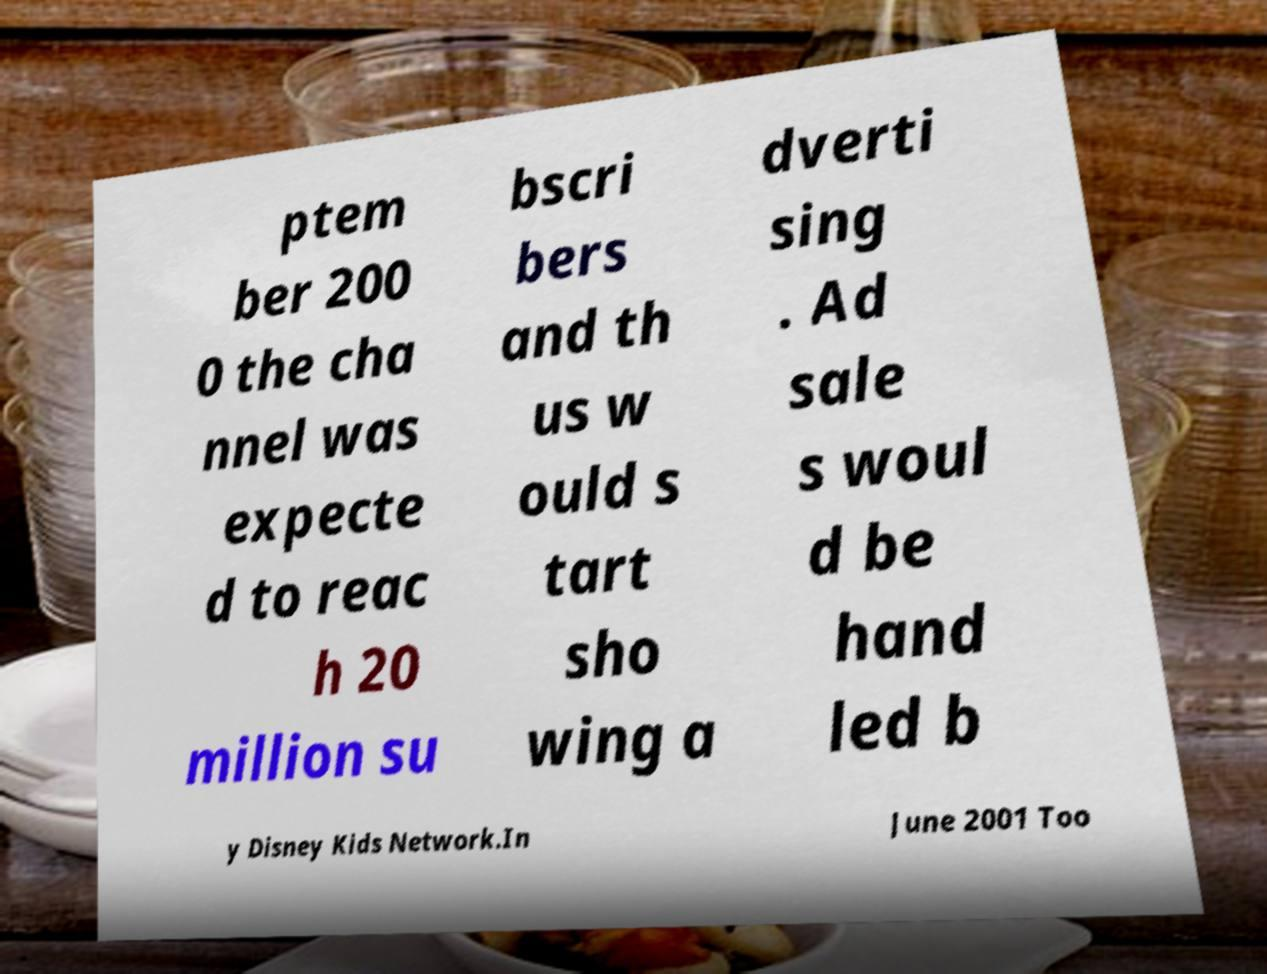Please identify and transcribe the text found in this image. ptem ber 200 0 the cha nnel was expecte d to reac h 20 million su bscri bers and th us w ould s tart sho wing a dverti sing . Ad sale s woul d be hand led b y Disney Kids Network.In June 2001 Too 